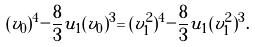<formula> <loc_0><loc_0><loc_500><loc_500>( v _ { 0 } ) ^ { 4 } - \frac { 8 } { 3 } u _ { 1 } ( v _ { 0 } ) ^ { 3 } = ( v ^ { 2 } _ { 1 } ) ^ { 4 } - \frac { 8 } { 3 } u _ { 1 } ( v ^ { 2 } _ { 1 } ) ^ { 3 } .</formula> 